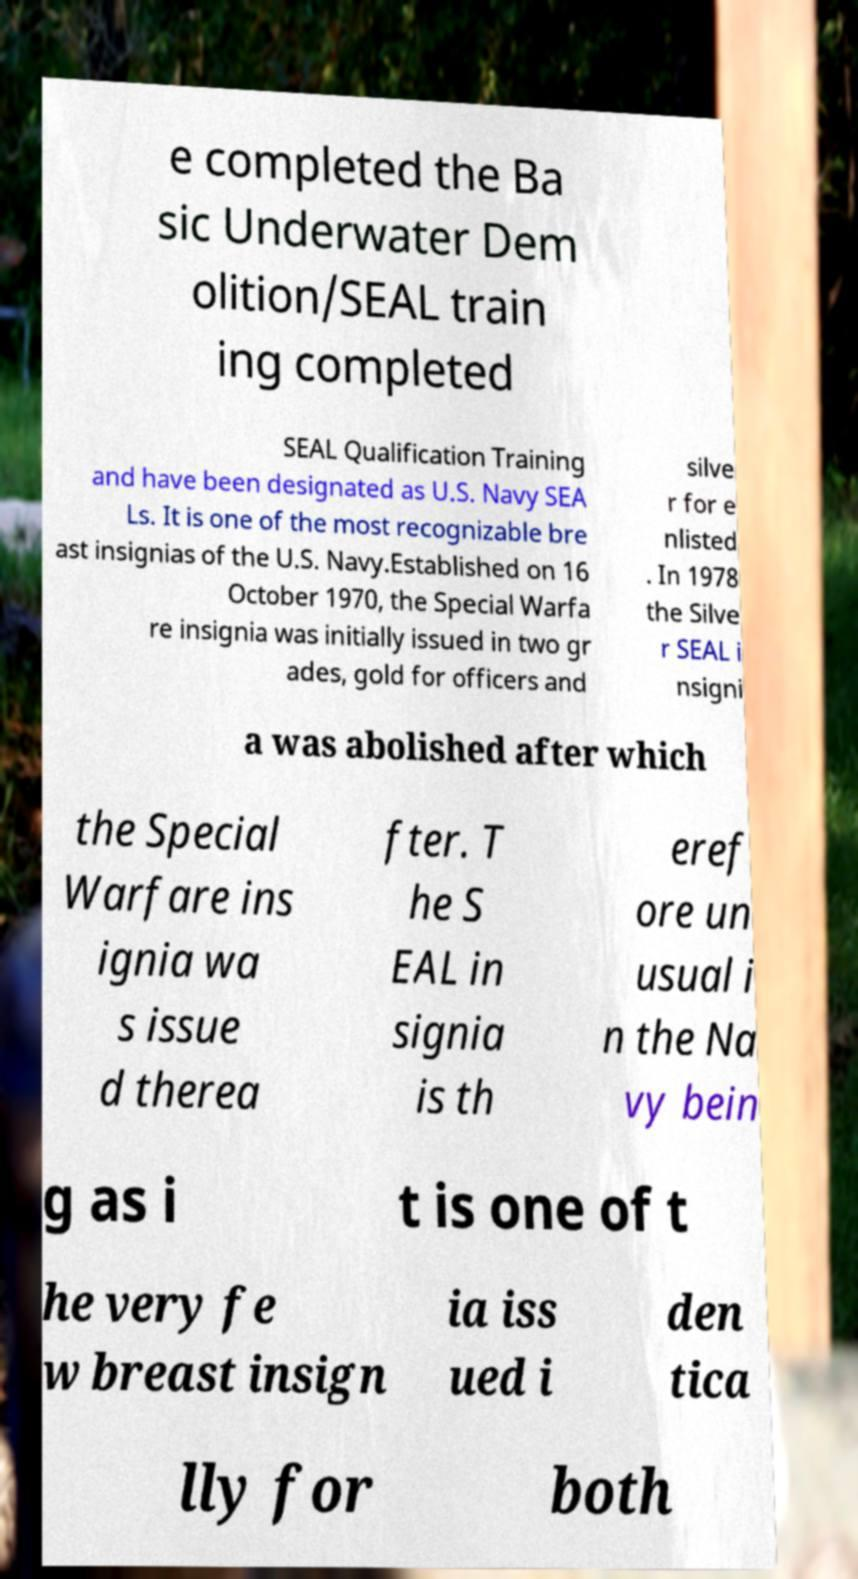Could you assist in decoding the text presented in this image and type it out clearly? e completed the Ba sic Underwater Dem olition/SEAL train ing completed SEAL Qualification Training and have been designated as U.S. Navy SEA Ls. It is one of the most recognizable bre ast insignias of the U.S. Navy.Established on 16 October 1970, the Special Warfa re insignia was initially issued in two gr ades, gold for officers and silve r for e nlisted . In 1978 the Silve r SEAL i nsigni a was abolished after which the Special Warfare ins ignia wa s issue d therea fter. T he S EAL in signia is th eref ore un usual i n the Na vy bein g as i t is one of t he very fe w breast insign ia iss ued i den tica lly for both 